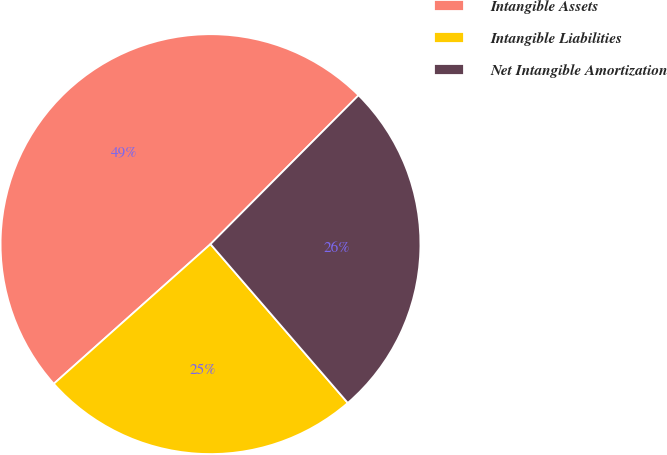Convert chart to OTSL. <chart><loc_0><loc_0><loc_500><loc_500><pie_chart><fcel>Intangible Assets<fcel>Intangible Liabilities<fcel>Net Intangible Amortization<nl><fcel>49.04%<fcel>24.76%<fcel>26.2%<nl></chart> 